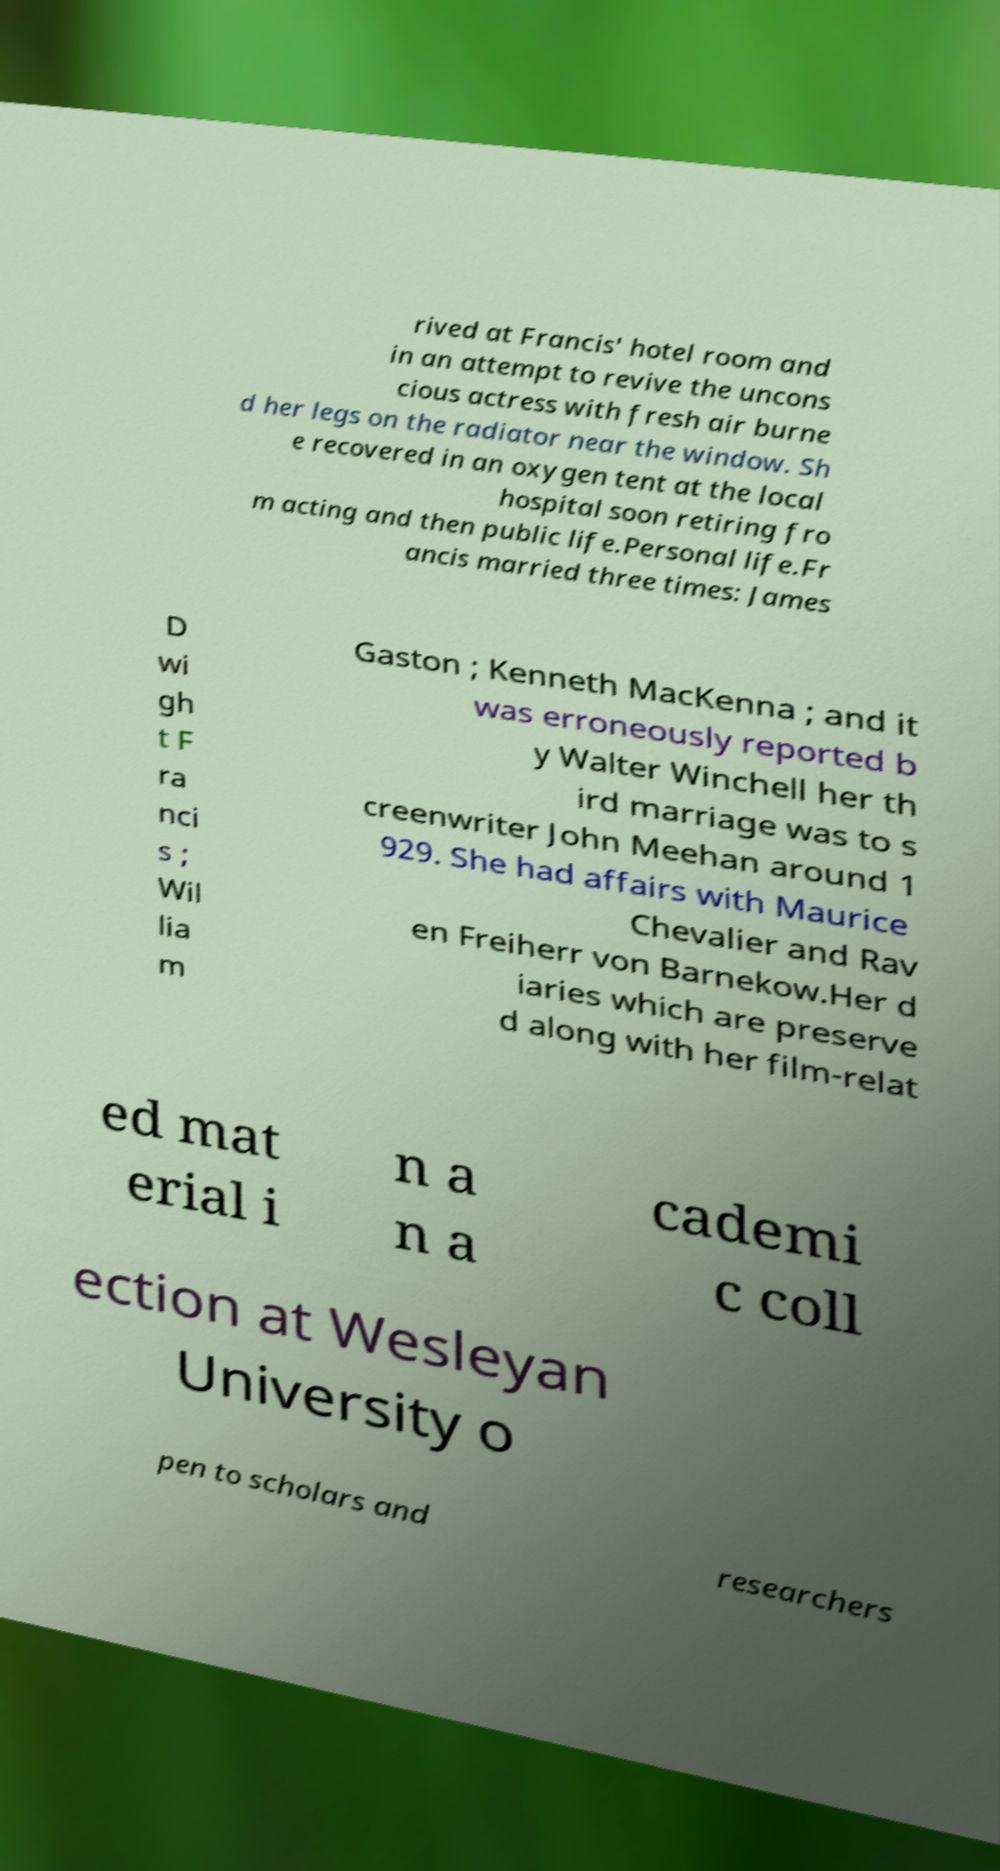What messages or text are displayed in this image? I need them in a readable, typed format. rived at Francis' hotel room and in an attempt to revive the uncons cious actress with fresh air burne d her legs on the radiator near the window. Sh e recovered in an oxygen tent at the local hospital soon retiring fro m acting and then public life.Personal life.Fr ancis married three times: James D wi gh t F ra nci s ; Wil lia m Gaston ; Kenneth MacKenna ; and it was erroneously reported b y Walter Winchell her th ird marriage was to s creenwriter John Meehan around 1 929. She had affairs with Maurice Chevalier and Rav en Freiherr von Barnekow.Her d iaries which are preserve d along with her film-relat ed mat erial i n a n a cademi c coll ection at Wesleyan University o pen to scholars and researchers 